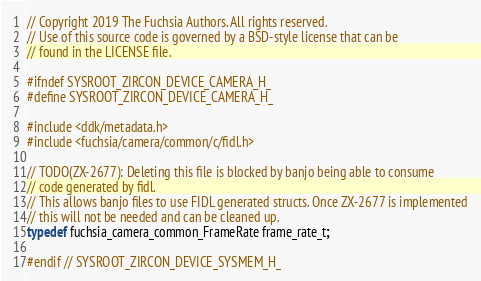<code> <loc_0><loc_0><loc_500><loc_500><_C_>// Copyright 2019 The Fuchsia Authors. All rights reserved.
// Use of this source code is governed by a BSD-style license that can be
// found in the LICENSE file.

#ifndef SYSROOT_ZIRCON_DEVICE_CAMERA_H_
#define SYSROOT_ZIRCON_DEVICE_CAMERA_H_

#include <ddk/metadata.h>
#include <fuchsia/camera/common/c/fidl.h>

// TODO(ZX-2677): Deleting this file is blocked by banjo being able to consume
// code generated by fidl.
// This allows banjo files to use FIDL generated structs. Once ZX-2677 is implemented
// this will not be needed and can be cleaned up.
typedef fuchsia_camera_common_FrameRate frame_rate_t;

#endif // SYSROOT_ZIRCON_DEVICE_SYSMEM_H_
</code> 